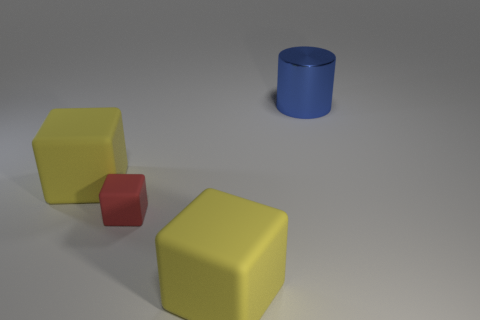Add 2 small red rubber blocks. How many objects exist? 6 Subtract all cubes. How many objects are left? 1 Subtract all small gray matte cylinders. Subtract all red rubber things. How many objects are left? 3 Add 1 large metal cylinders. How many large metal cylinders are left? 2 Add 4 large blocks. How many large blocks exist? 6 Subtract 0 cyan cylinders. How many objects are left? 4 